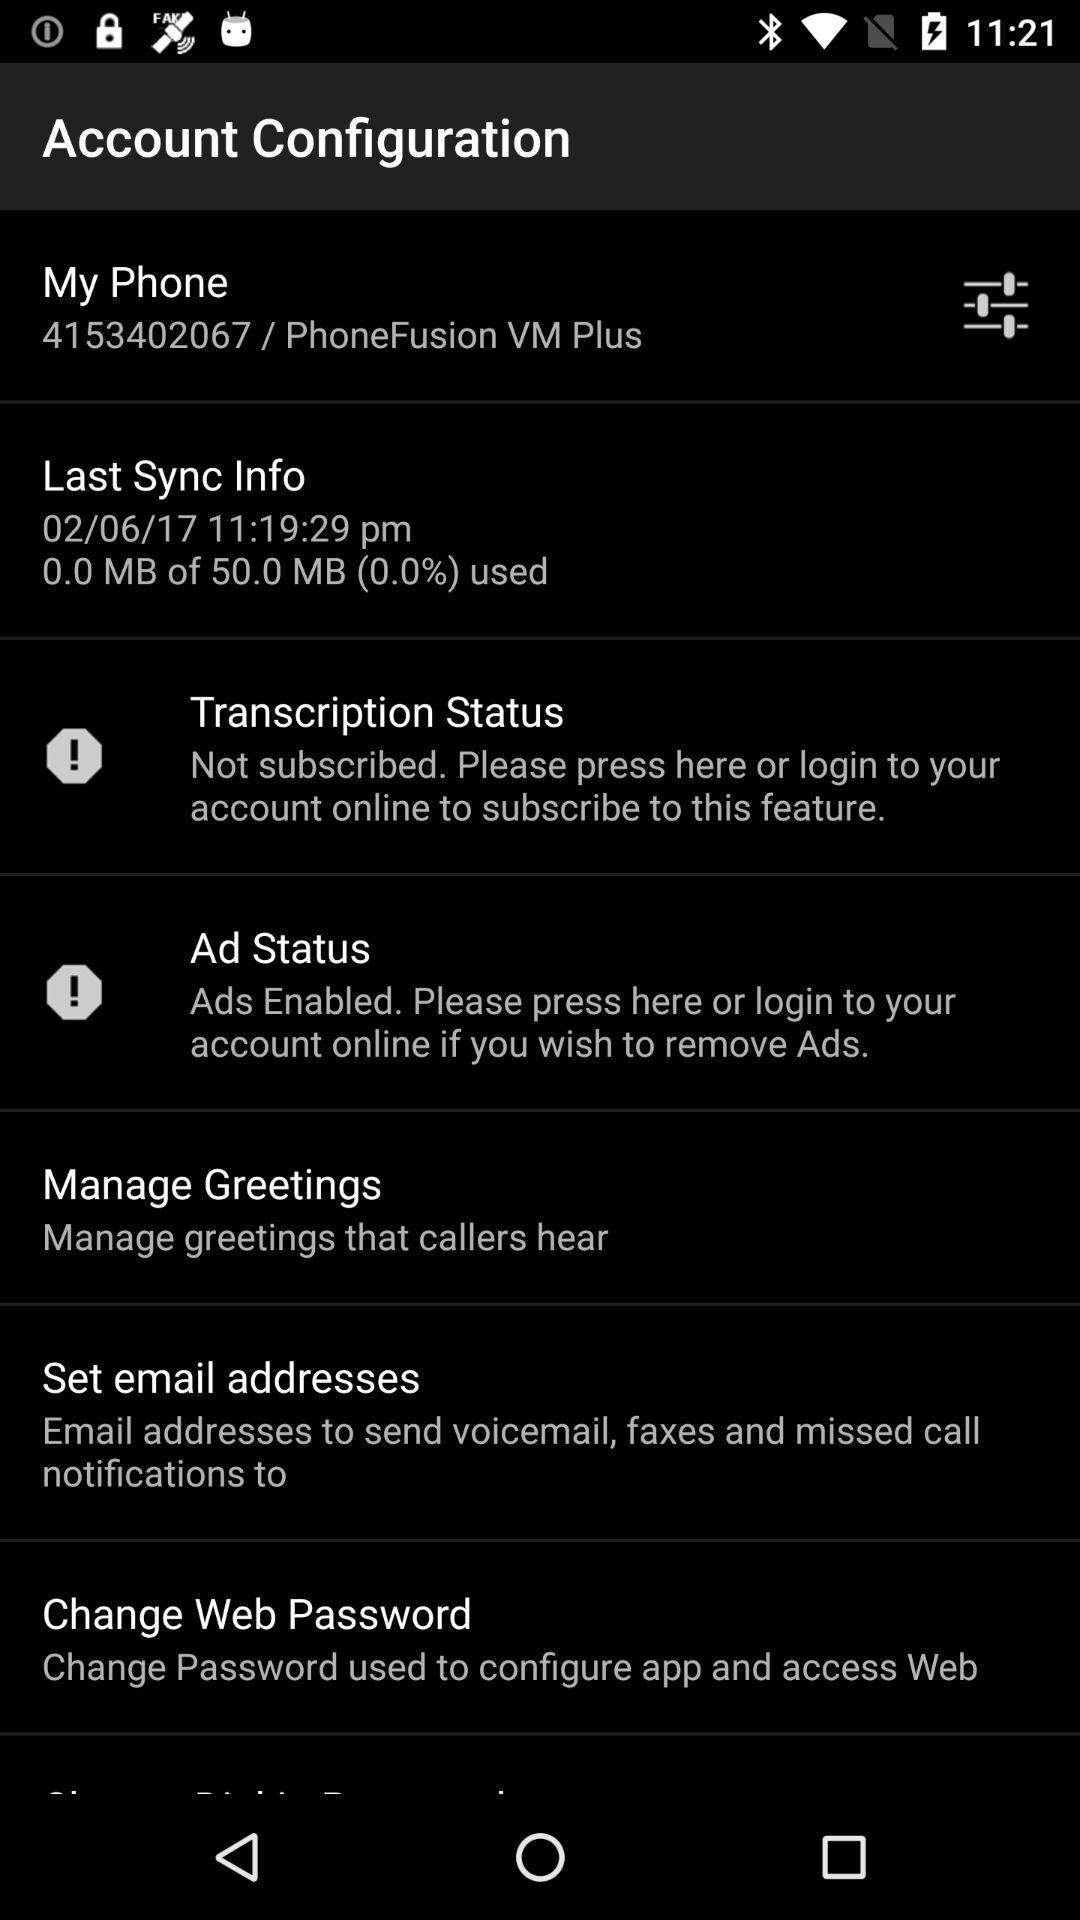What is the status of transcription? The status is "Not subscribed". 